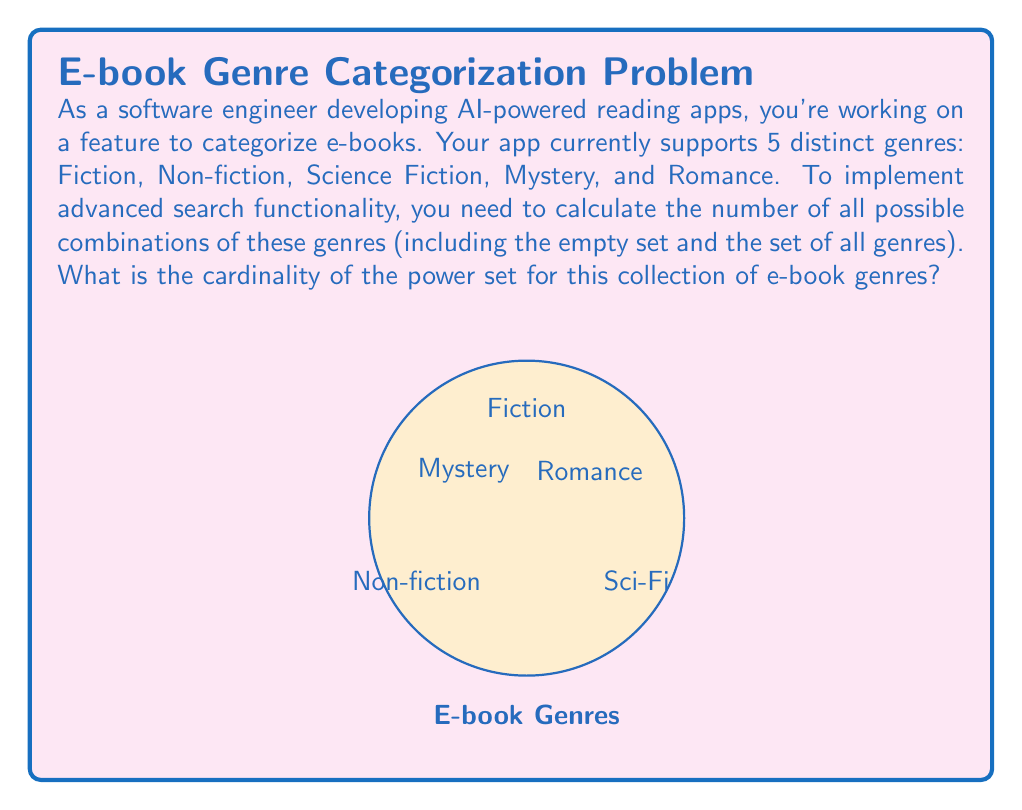Could you help me with this problem? Let's approach this step-by-step:

1) First, recall that for a set $S$ with $n$ elements, the cardinality of its power set $P(S)$ is given by the formula:

   $$ |P(S)| = 2^n $$

2) In this case, we have 5 distinct genres:
   - Fiction
   - Non-fiction
   - Science Fiction
   - Mystery
   - Romance

3) Therefore, $n = 5$

4) Applying the formula:

   $$ |P(S)| = 2^5 $$

5) Calculate $2^5$:
   $$ 2^5 = 2 \times 2 \times 2 \times 2 \times 2 = 32 $$

6) This result, 32, represents all possible combinations:
   - The empty set (no genres selected)
   - 5 sets with one genre each
   - 10 sets with two genres each
   - 10 sets with three genres each
   - 5 sets with four genres each
   - 1 set with all five genres

The sum of these is indeed $1 + 5 + 10 + 10 + 5 + 1 = 32$
Answer: $32$ 